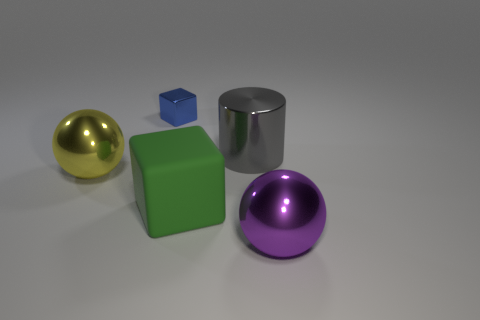What materials do these objects appear to be made of? The objects in the image appear to be digital renderings rather than physical materials. They seem to represent a gold-colored sphere, a cobalt blue cube, a chrome cylinder, a green cube, and a purple sphere, each with a distinct glossy surface simulating different materials like metal or plastic. 